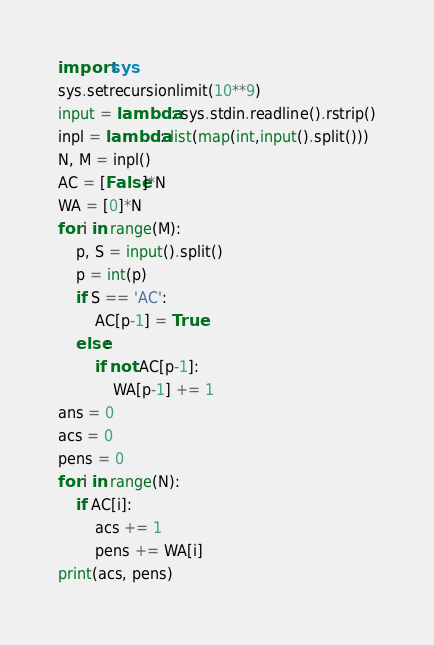<code> <loc_0><loc_0><loc_500><loc_500><_Python_>import sys
sys.setrecursionlimit(10**9)
input = lambda: sys.stdin.readline().rstrip()
inpl = lambda: list(map(int,input().split()))
N, M = inpl()
AC = [False]*N
WA = [0]*N
for i in range(M):
    p, S = input().split()
    p = int(p)
    if S == 'AC':
        AC[p-1] = True
    else:
        if not AC[p-1]:
            WA[p-1] += 1
ans = 0
acs = 0
pens = 0
for i in range(N):
    if AC[i]:
        acs += 1
        pens += WA[i]
print(acs, pens)</code> 